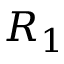Convert formula to latex. <formula><loc_0><loc_0><loc_500><loc_500>R _ { 1 }</formula> 